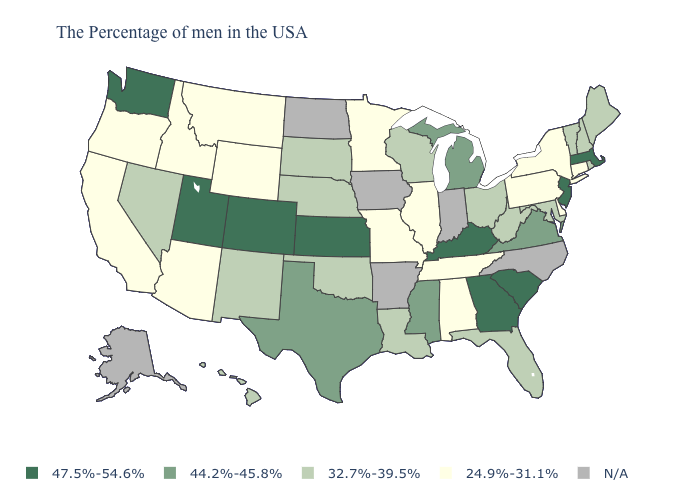How many symbols are there in the legend?
Quick response, please. 5. Does the map have missing data?
Short answer required. Yes. Name the states that have a value in the range 24.9%-31.1%?
Keep it brief. Connecticut, New York, Delaware, Pennsylvania, Alabama, Tennessee, Illinois, Missouri, Minnesota, Wyoming, Montana, Arizona, Idaho, California, Oregon. What is the lowest value in the USA?
Give a very brief answer. 24.9%-31.1%. What is the value of California?
Concise answer only. 24.9%-31.1%. What is the value of Ohio?
Short answer required. 32.7%-39.5%. Name the states that have a value in the range 32.7%-39.5%?
Answer briefly. Maine, Rhode Island, New Hampshire, Vermont, Maryland, West Virginia, Ohio, Florida, Wisconsin, Louisiana, Nebraska, Oklahoma, South Dakota, New Mexico, Nevada, Hawaii. What is the lowest value in the USA?
Give a very brief answer. 24.9%-31.1%. Name the states that have a value in the range 32.7%-39.5%?
Quick response, please. Maine, Rhode Island, New Hampshire, Vermont, Maryland, West Virginia, Ohio, Florida, Wisconsin, Louisiana, Nebraska, Oklahoma, South Dakota, New Mexico, Nevada, Hawaii. What is the value of New York?
Be succinct. 24.9%-31.1%. Name the states that have a value in the range N/A?
Give a very brief answer. North Carolina, Indiana, Arkansas, Iowa, North Dakota, Alaska. Does the first symbol in the legend represent the smallest category?
Give a very brief answer. No. What is the highest value in states that border Idaho?
Short answer required. 47.5%-54.6%. 